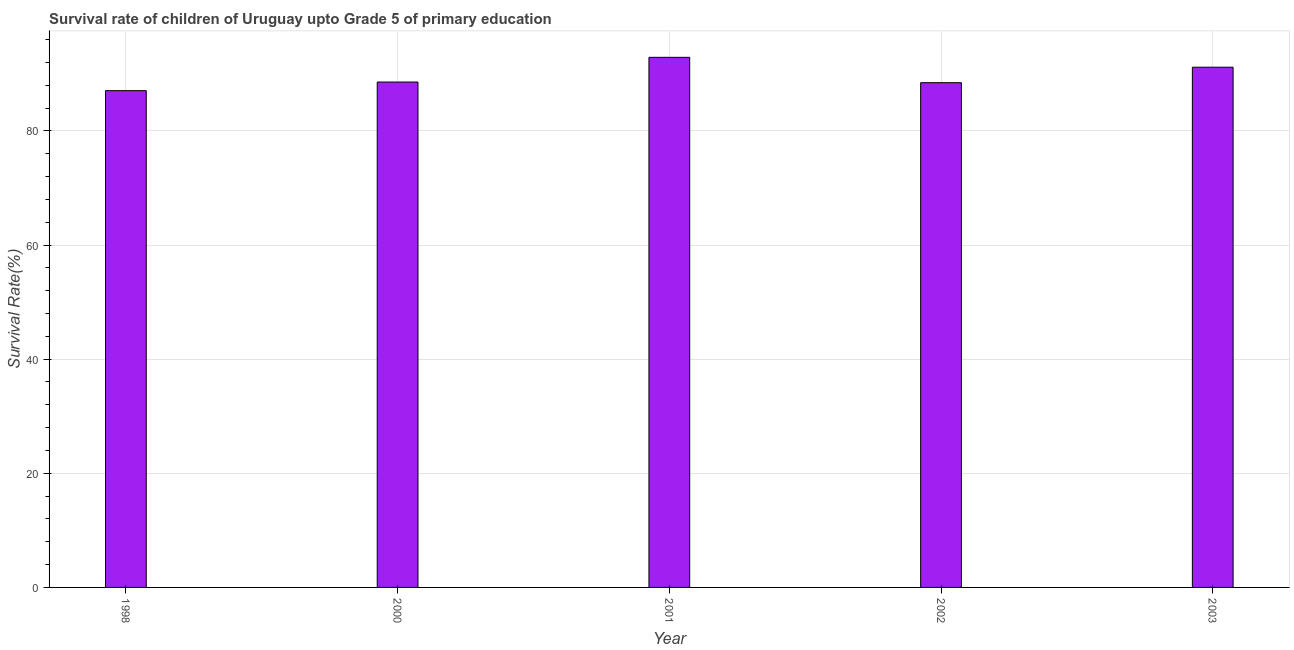Does the graph contain any zero values?
Provide a succinct answer. No. What is the title of the graph?
Your response must be concise. Survival rate of children of Uruguay upto Grade 5 of primary education. What is the label or title of the Y-axis?
Provide a short and direct response. Survival Rate(%). What is the survival rate in 2000?
Your answer should be very brief. 88.57. Across all years, what is the maximum survival rate?
Your answer should be compact. 92.89. Across all years, what is the minimum survival rate?
Ensure brevity in your answer.  87.05. In which year was the survival rate minimum?
Make the answer very short. 1998. What is the sum of the survival rate?
Your response must be concise. 448.14. What is the difference between the survival rate in 1998 and 2003?
Make the answer very short. -4.11. What is the average survival rate per year?
Ensure brevity in your answer.  89.63. What is the median survival rate?
Your answer should be compact. 88.57. In how many years, is the survival rate greater than 8 %?
Your answer should be compact. 5. Is the difference between the survival rate in 2000 and 2002 greater than the difference between any two years?
Ensure brevity in your answer.  No. What is the difference between the highest and the second highest survival rate?
Your response must be concise. 1.73. What is the difference between the highest and the lowest survival rate?
Your response must be concise. 5.84. How many bars are there?
Offer a terse response. 5. Are all the bars in the graph horizontal?
Provide a short and direct response. No. How many years are there in the graph?
Your answer should be compact. 5. Are the values on the major ticks of Y-axis written in scientific E-notation?
Provide a succinct answer. No. What is the Survival Rate(%) in 1998?
Make the answer very short. 87.05. What is the Survival Rate(%) in 2000?
Your response must be concise. 88.57. What is the Survival Rate(%) of 2001?
Your response must be concise. 92.89. What is the Survival Rate(%) of 2002?
Provide a succinct answer. 88.45. What is the Survival Rate(%) in 2003?
Give a very brief answer. 91.17. What is the difference between the Survival Rate(%) in 1998 and 2000?
Your answer should be very brief. -1.51. What is the difference between the Survival Rate(%) in 1998 and 2001?
Make the answer very short. -5.84. What is the difference between the Survival Rate(%) in 1998 and 2002?
Offer a very short reply. -1.4. What is the difference between the Survival Rate(%) in 1998 and 2003?
Provide a succinct answer. -4.11. What is the difference between the Survival Rate(%) in 2000 and 2001?
Keep it short and to the point. -4.33. What is the difference between the Survival Rate(%) in 2000 and 2002?
Offer a terse response. 0.11. What is the difference between the Survival Rate(%) in 2000 and 2003?
Offer a very short reply. -2.6. What is the difference between the Survival Rate(%) in 2001 and 2002?
Your response must be concise. 4.44. What is the difference between the Survival Rate(%) in 2001 and 2003?
Ensure brevity in your answer.  1.73. What is the difference between the Survival Rate(%) in 2002 and 2003?
Keep it short and to the point. -2.71. What is the ratio of the Survival Rate(%) in 1998 to that in 2001?
Offer a terse response. 0.94. What is the ratio of the Survival Rate(%) in 1998 to that in 2002?
Offer a terse response. 0.98. What is the ratio of the Survival Rate(%) in 1998 to that in 2003?
Provide a succinct answer. 0.95. What is the ratio of the Survival Rate(%) in 2000 to that in 2001?
Keep it short and to the point. 0.95. What is the ratio of the Survival Rate(%) in 2000 to that in 2002?
Offer a terse response. 1. What is the ratio of the Survival Rate(%) in 2001 to that in 2002?
Provide a short and direct response. 1.05. What is the ratio of the Survival Rate(%) in 2002 to that in 2003?
Make the answer very short. 0.97. 